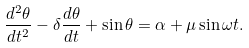<formula> <loc_0><loc_0><loc_500><loc_500>\frac { d ^ { 2 } \theta } { d t ^ { 2 } } - \delta \frac { d \theta } { d t } + \sin \theta = \alpha + \mu \sin \omega t .</formula> 